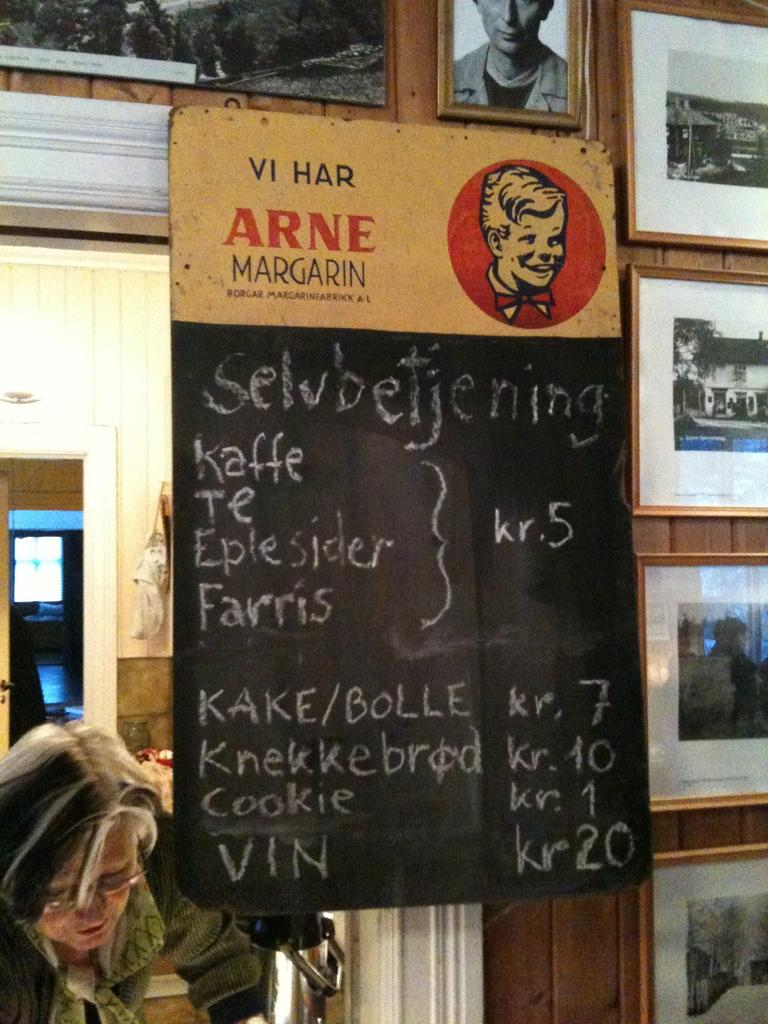What is the main object in the foreground of the image? There is a blackboard in the foreground of the image. What is written on the blackboard? There is text written on the blackboard. What can be seen on the wall in the image? There are frames on the wall. Can you describe the person visible in the image? There is a person visible in the image, but their appearance or actions are not specified. What architectural feature is present in the image? There is a door in the image. What type of surface is visible in the image? There is a wall in the image. What source of illumination is present in the image? There is a light in the image. What advice does the person in the image give to the elbow? There is no advice given to an elbow in the image, as there is no mention of an elbow or any interaction between the person and an elbow. 